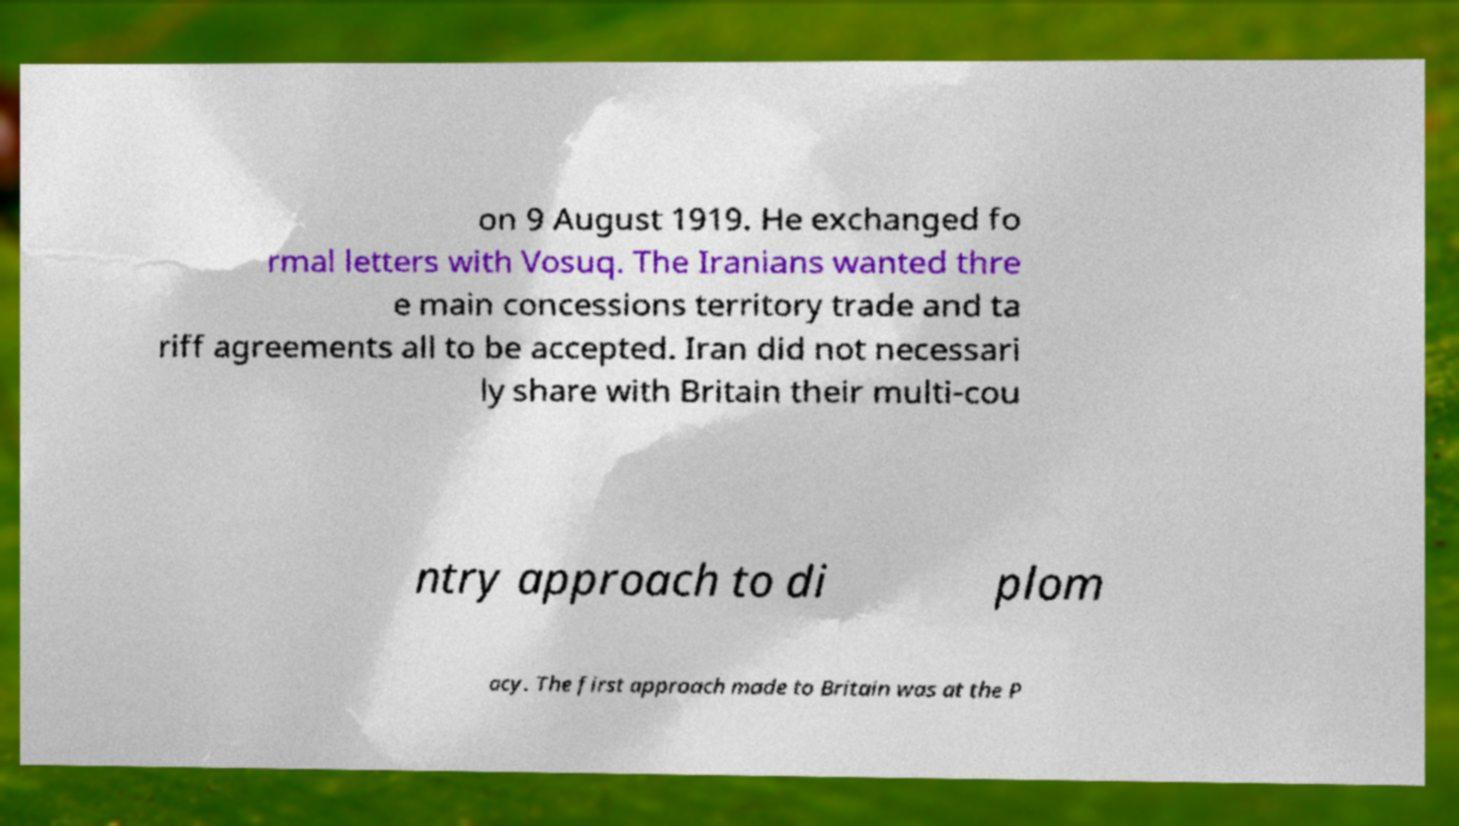Can you accurately transcribe the text from the provided image for me? on 9 August 1919. He exchanged fo rmal letters with Vosuq. The Iranians wanted thre e main concessions territory trade and ta riff agreements all to be accepted. Iran did not necessari ly share with Britain their multi-cou ntry approach to di plom acy. The first approach made to Britain was at the P 